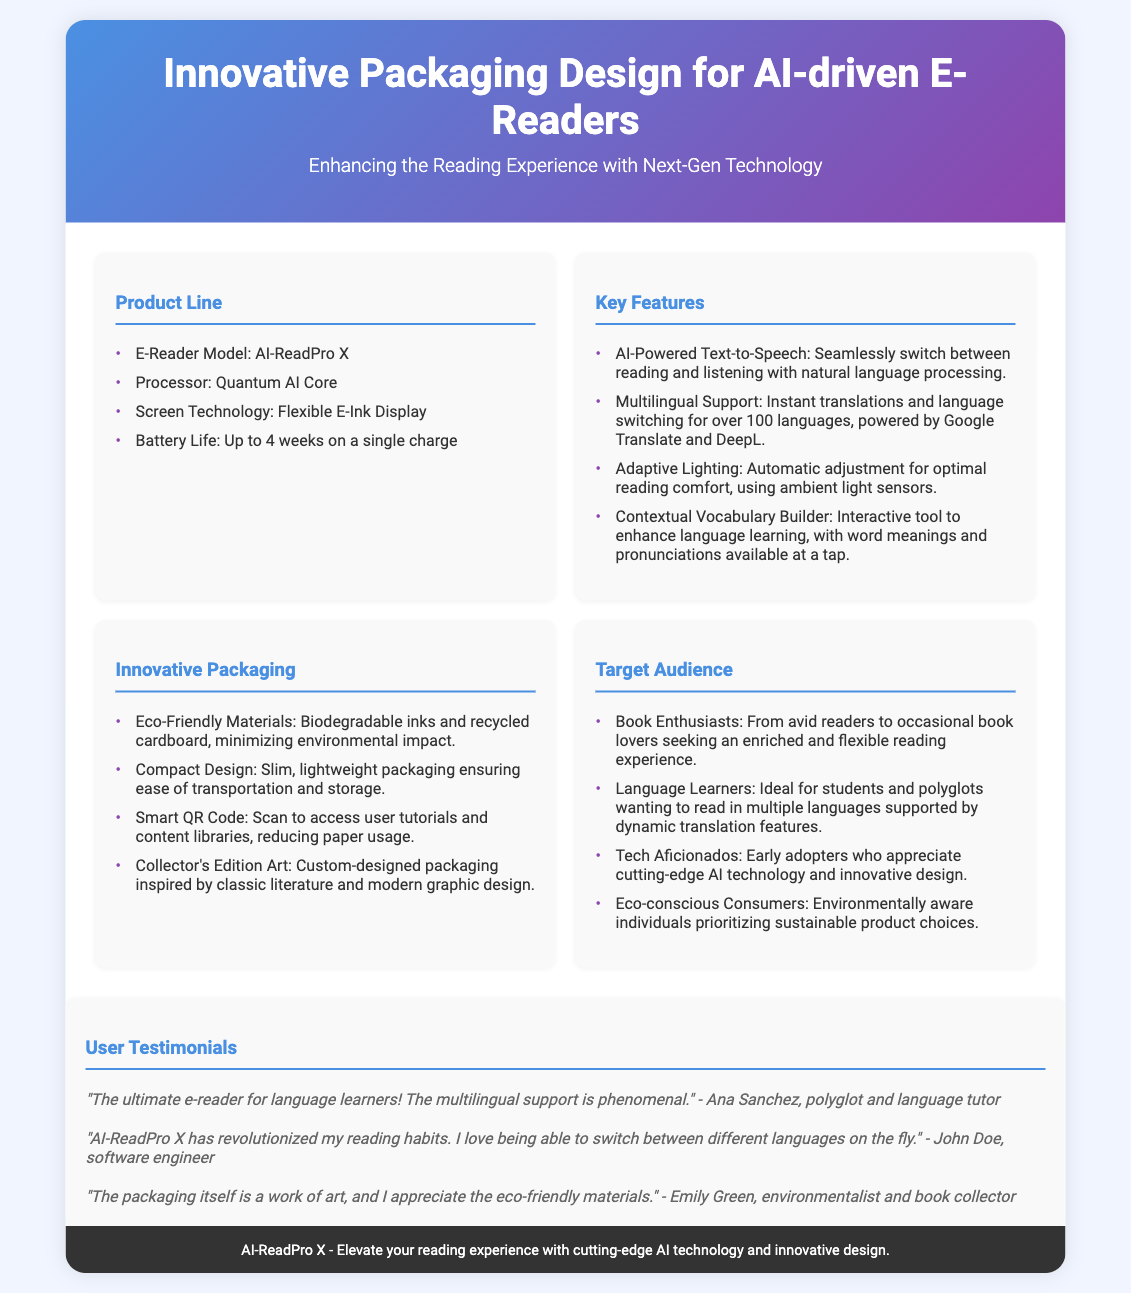What is the model name of the e-reader? The model name of the e-reader mentioned in the document is AI-ReadPro X.
Answer: AI-ReadPro X How long is the battery life of the e-reader? The battery life stated in the document is up to 4 weeks on a single charge.
Answer: 4 weeks What technology is used for screen display? The screen technology used for the e-reader is Flexible E-Ink Display.
Answer: Flexible E-Ink Display How many languages does the multilingual support cover? The document states that the multilingual support is for over 100 languages.
Answer: over 100 languages What kind of materials are used in the packaging? The packaging uses eco-friendly materials, specifically biodegradable inks and recycled cardboard.
Answer: eco-friendly materials Who is the target audience that includes language learners? The target audience includes students and polyglots wanting to read in multiple languages.
Answer: students and polyglots What feature allows for automatic light adjustment? Adaptive Lighting is the feature that allows for automatic adjustment for optimal reading comfort.
Answer: Adaptive Lighting Who praised the packaging as a work of art? Emily Green is the person who praised the packaging as a work of art.
Answer: Emily Green What is the primary purpose of the smart QR code? The smart QR code's purpose is to access user tutorials and content libraries, reducing paper usage.
Answer: access user tutorials and content libraries 